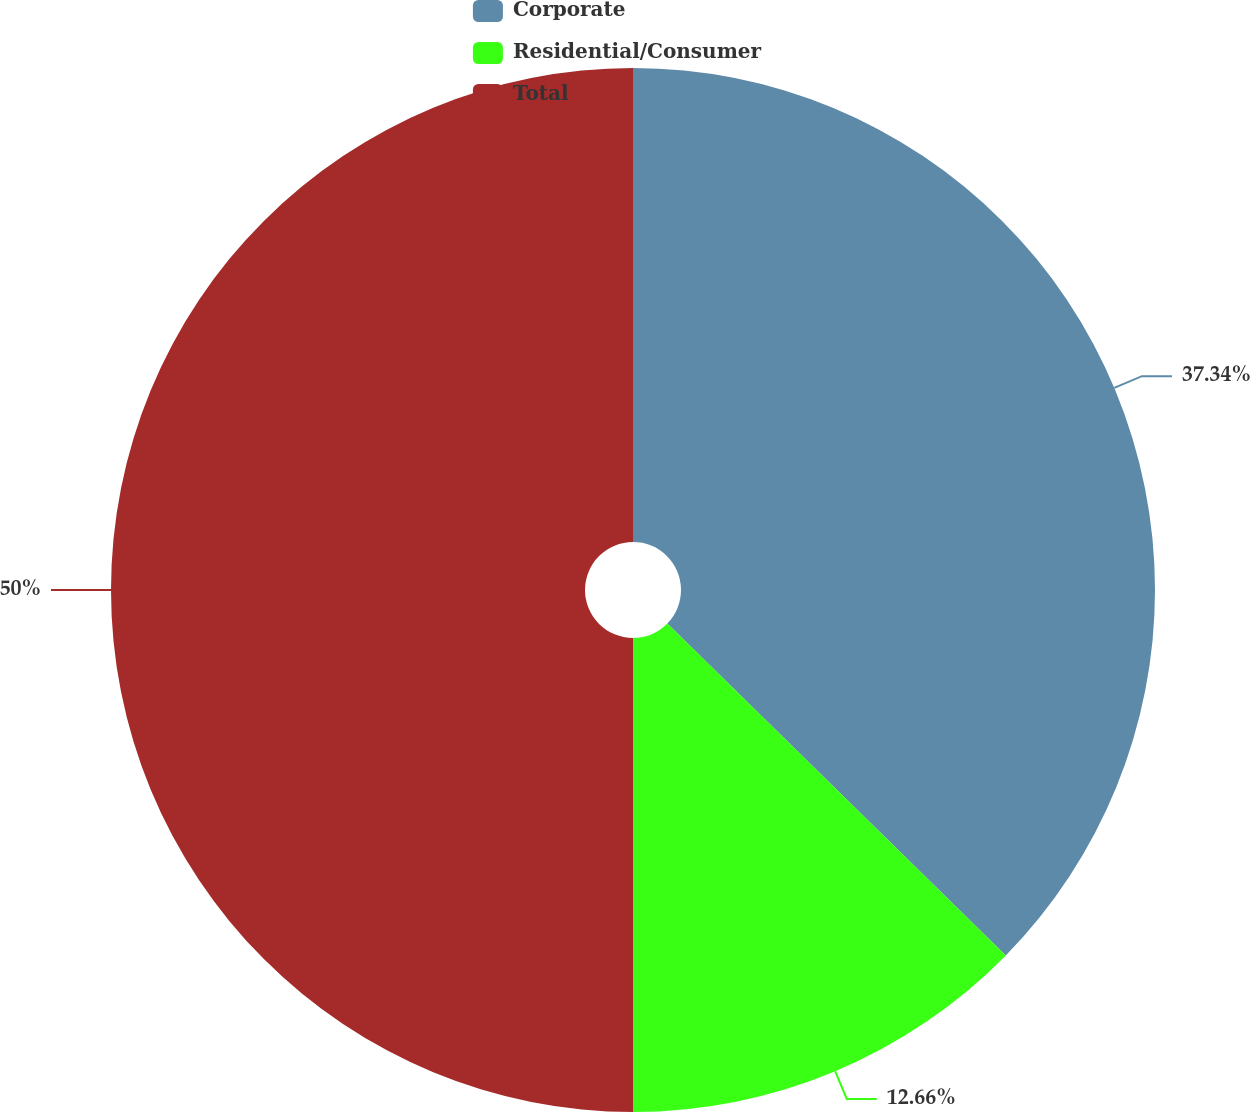Convert chart. <chart><loc_0><loc_0><loc_500><loc_500><pie_chart><fcel>Corporate<fcel>Residential/Consumer<fcel>Total<nl><fcel>37.34%<fcel>12.66%<fcel>50.0%<nl></chart> 